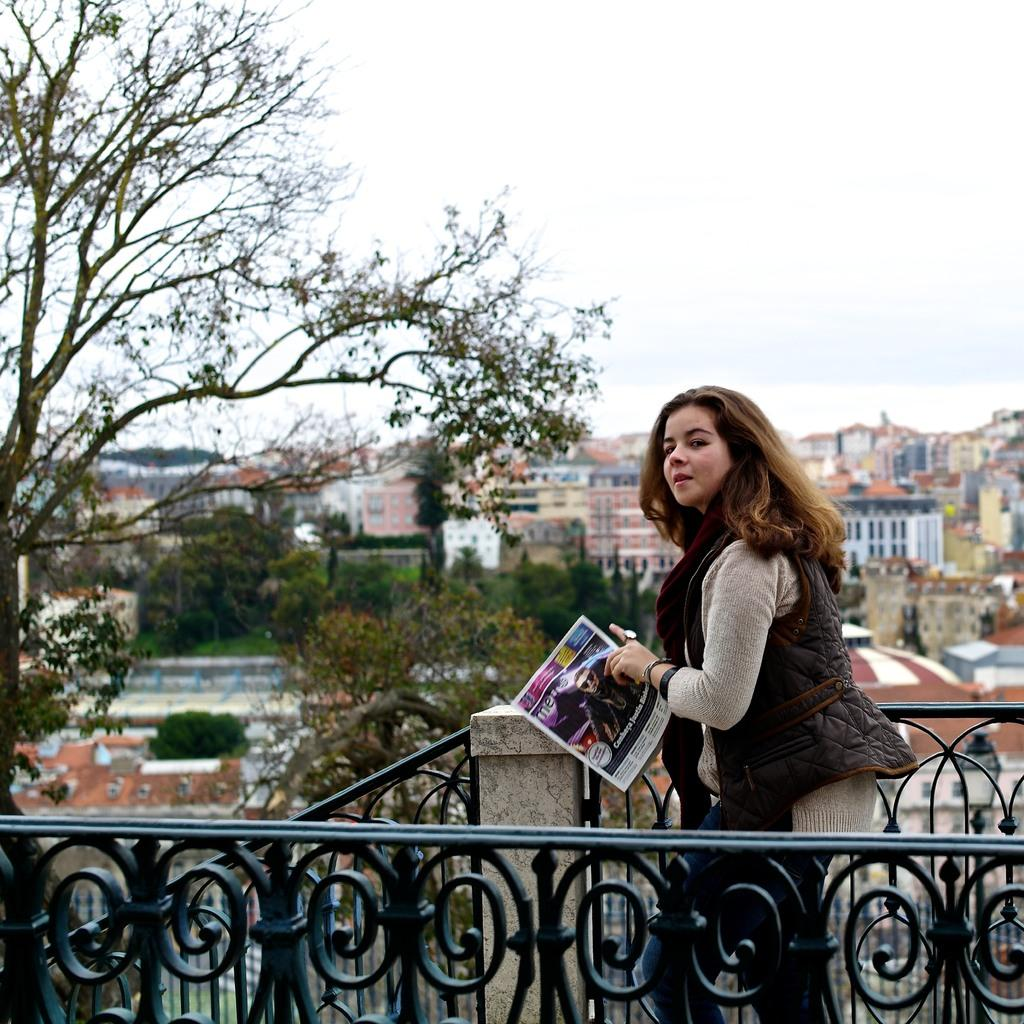What is the main subject of the image? There is a woman in the image. What is the woman doing in the image? The woman is standing in the image. What is the woman holding in her hand? The woman is holding a newspaper in her hand. What can be seen in the background of the image? There are trees and buildings in the background of the image. What architectural feature is present in the image? There is a railing in the image. What type of growth can be seen on the woman's head in the image? There is no growth visible on the woman's head in the image. What kind of bulb is illuminating the scene in the image? There is no bulb present in the image; it is a photograph taken during the day, as indicated by the presence of sunlight. 